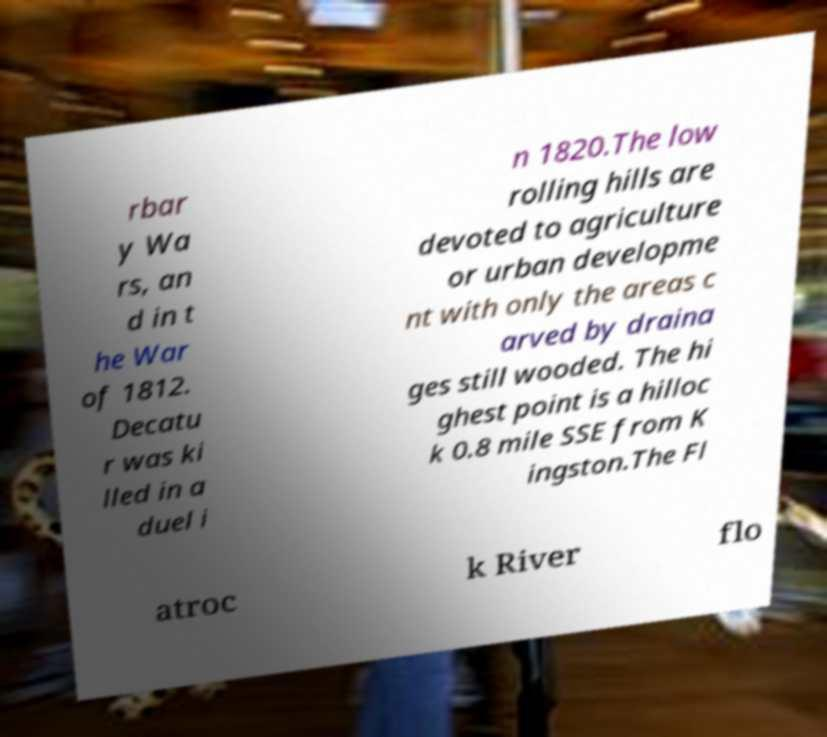Could you extract and type out the text from this image? rbar y Wa rs, an d in t he War of 1812. Decatu r was ki lled in a duel i n 1820.The low rolling hills are devoted to agriculture or urban developme nt with only the areas c arved by draina ges still wooded. The hi ghest point is a hilloc k 0.8 mile SSE from K ingston.The Fl atroc k River flo 